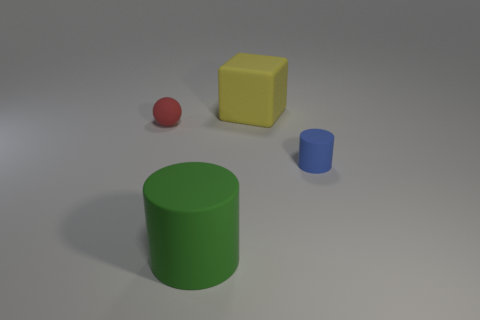Add 4 blue things. How many objects exist? 8 Subtract 0 gray cylinders. How many objects are left? 4 Subtract all cubes. How many objects are left? 3 Subtract all cyan cylinders. Subtract all gray balls. How many cylinders are left? 2 Subtract all small cyan metal cylinders. Subtract all big yellow rubber cubes. How many objects are left? 3 Add 4 large yellow objects. How many large yellow objects are left? 5 Add 2 small gray matte cylinders. How many small gray matte cylinders exist? 2 